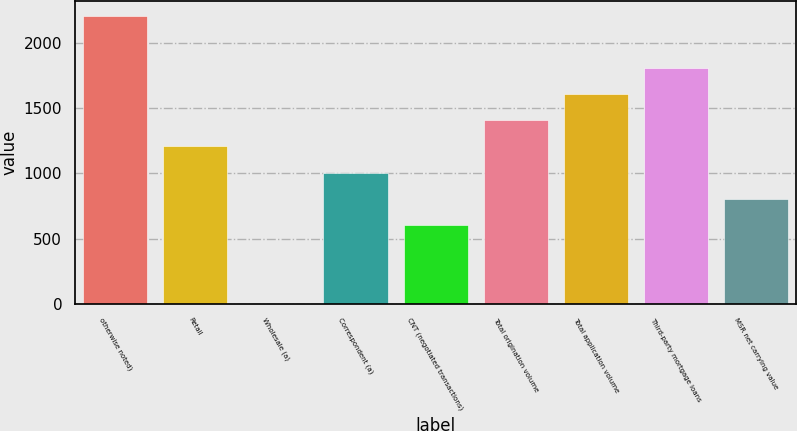Convert chart. <chart><loc_0><loc_0><loc_500><loc_500><bar_chart><fcel>otherwise noted)<fcel>Retail<fcel>Wholesale (a)<fcel>Correspondent (a)<fcel>CNT (negotiated transactions)<fcel>Total origination volume<fcel>Total application volume<fcel>Third-party mortgage loans<fcel>MSR net carrying value<nl><fcel>2213.17<fcel>1207.32<fcel>0.3<fcel>1006.15<fcel>603.81<fcel>1408.49<fcel>1609.66<fcel>1810.83<fcel>804.98<nl></chart> 